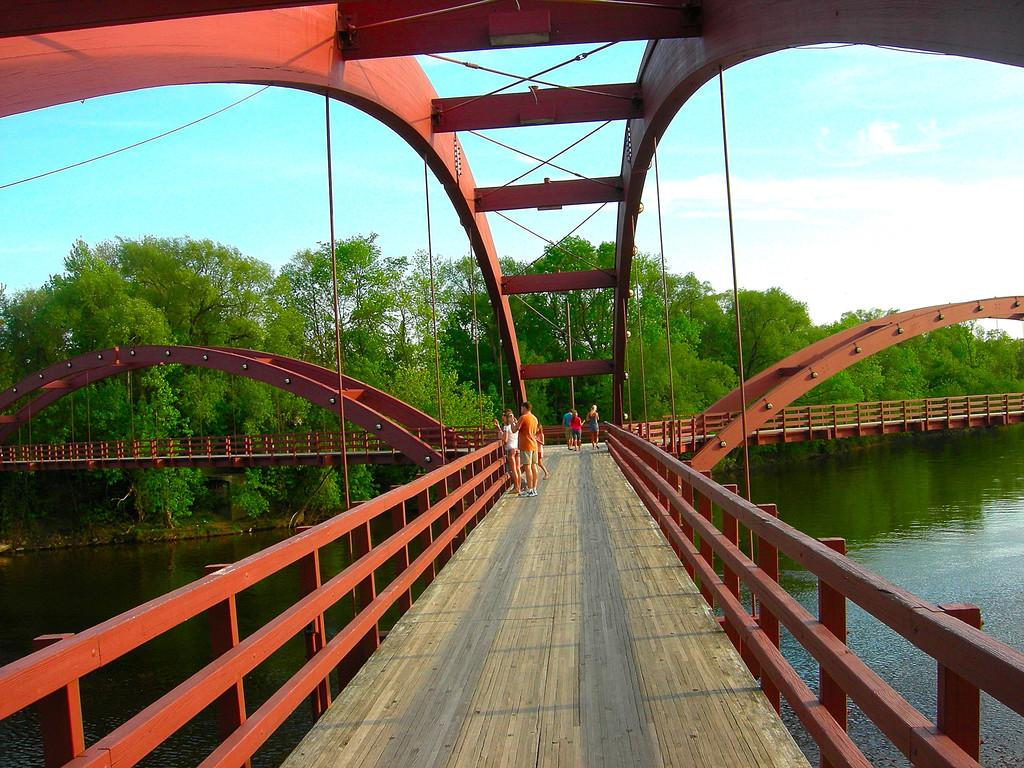How many people are in the image? There is a group of people in the image, but the exact number is not specified. Where are the people standing in the image? The people are standing on a bridge in the image. What can be seen in the background of the image? Trees and the sky are visible in the image. What is the condition of the sky in the image? The sky is visible in the image, and there are clouds present. What is visible below the bridge in the image? There is water visible in the image. What type of grain can be seen growing on the boundary of the bridge in the image? There is no grain visible in the image, nor is there any boundary on the bridge. 